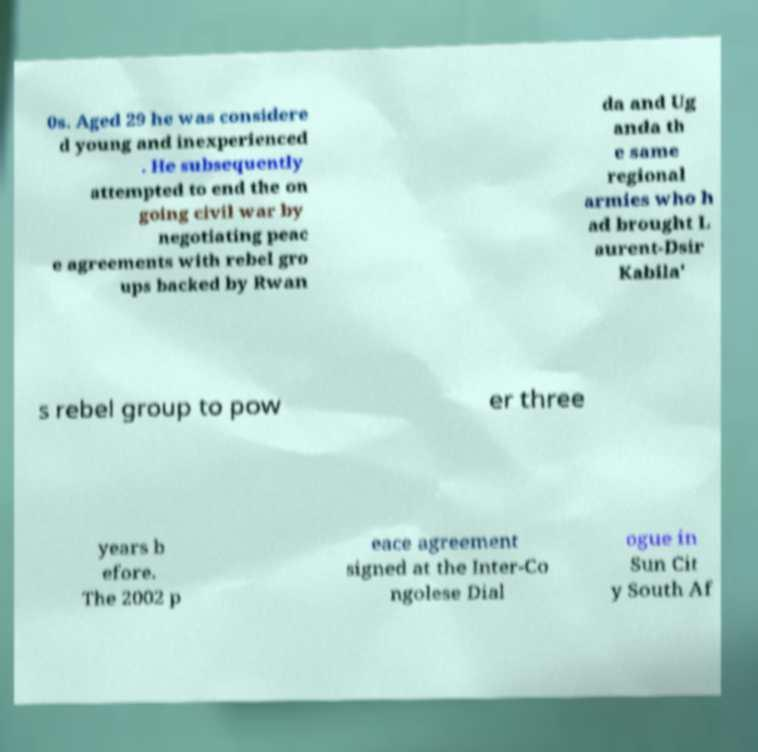Could you extract and type out the text from this image? 0s. Aged 29 he was considere d young and inexperienced . He subsequently attempted to end the on going civil war by negotiating peac e agreements with rebel gro ups backed by Rwan da and Ug anda th e same regional armies who h ad brought L aurent-Dsir Kabila' s rebel group to pow er three years b efore. The 2002 p eace agreement signed at the Inter-Co ngolese Dial ogue in Sun Cit y South Af 